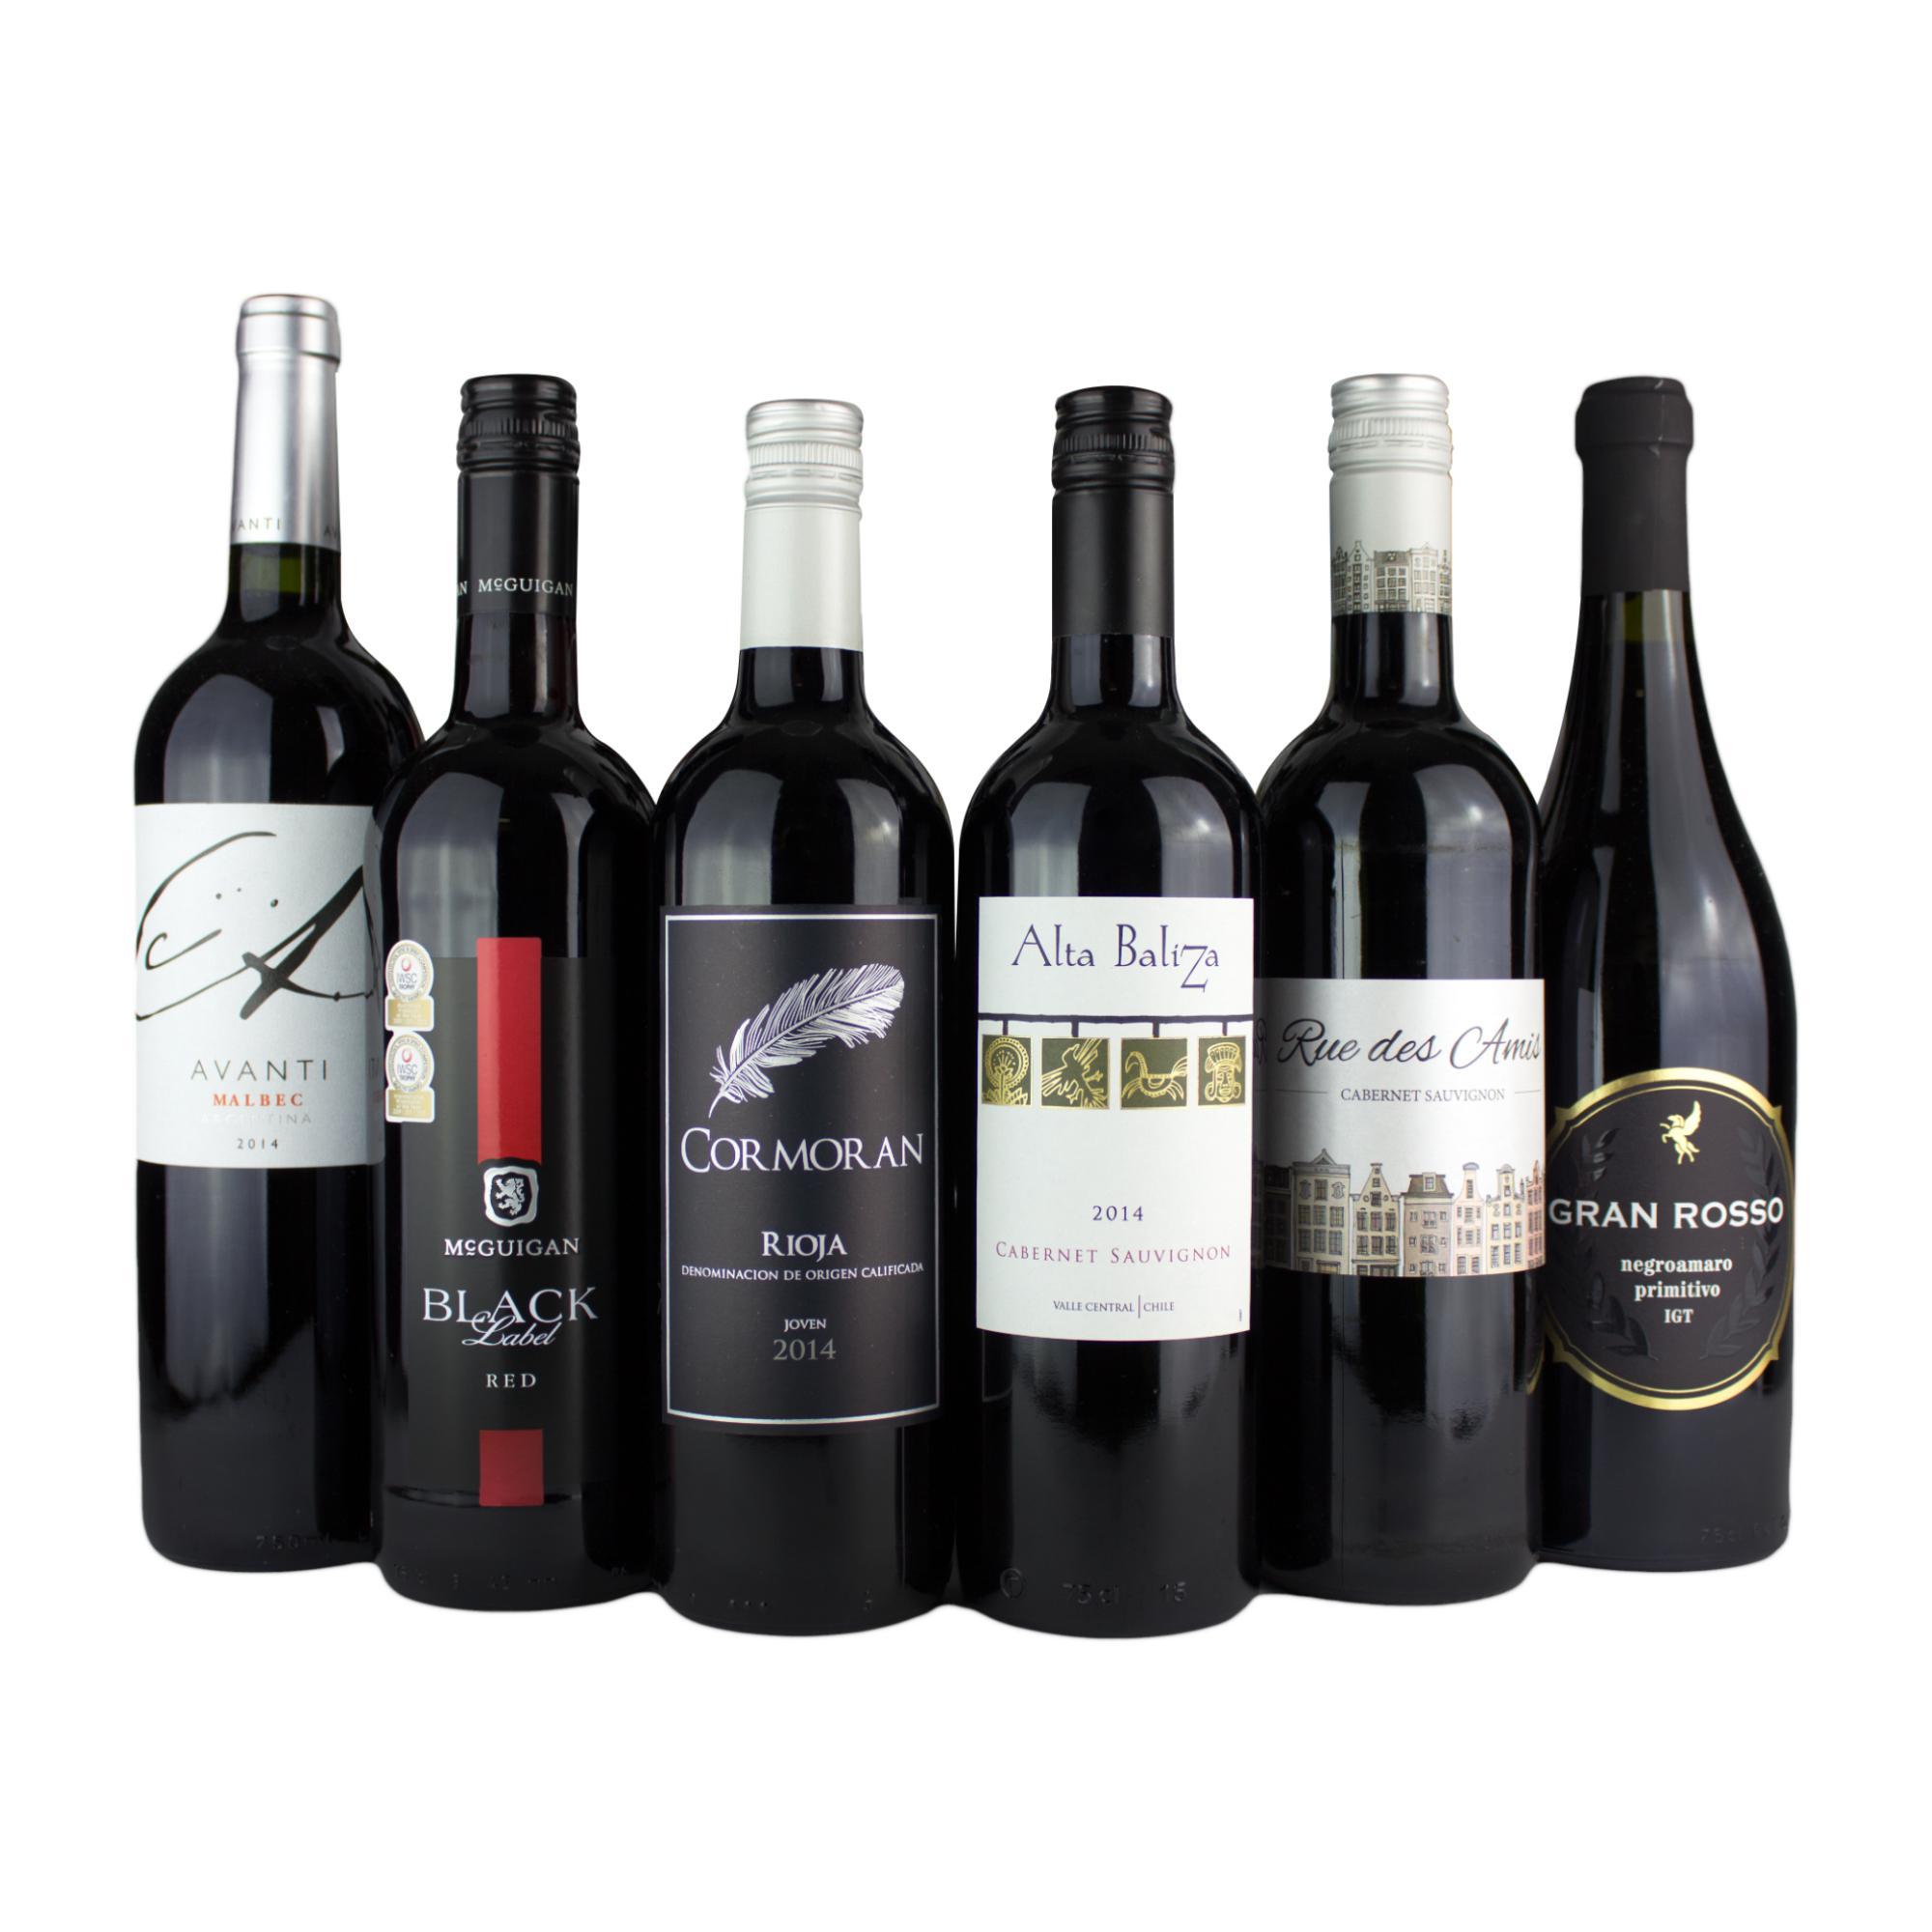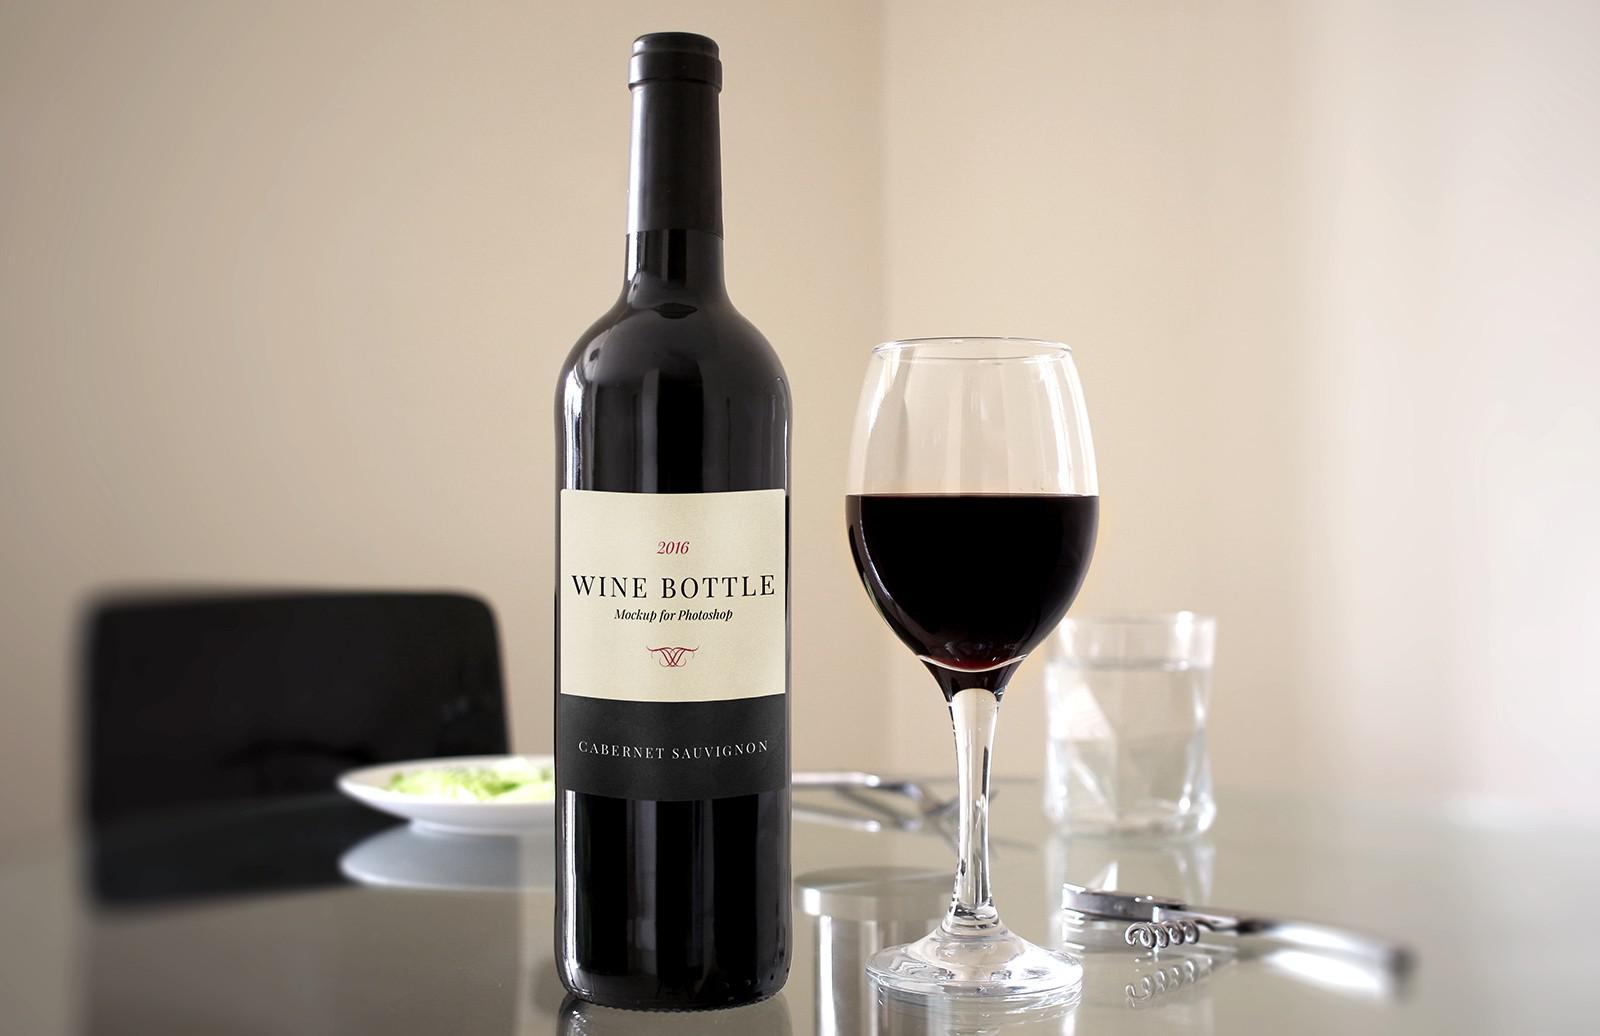The first image is the image on the left, the second image is the image on the right. Considering the images on both sides, is "There are at least six wine bottles in one of the images." valid? Answer yes or no. Yes. The first image is the image on the left, the second image is the image on the right. For the images shown, is this caption "In one of the images, there are two glasses of red wine side by side" true? Answer yes or no. No. 